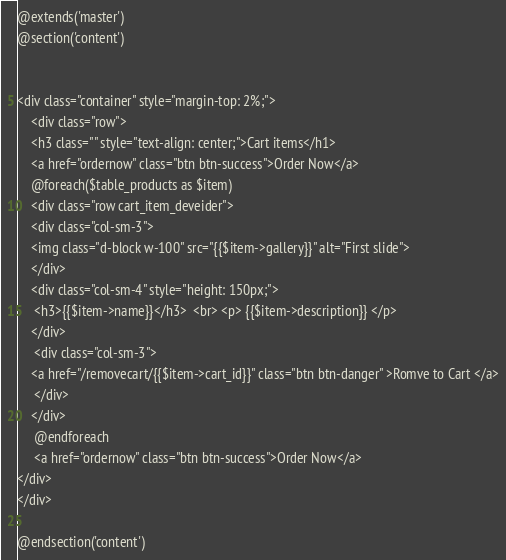Convert code to text. <code><loc_0><loc_0><loc_500><loc_500><_PHP_>@extends('master')
@section('content')


<div class="container" style="margin-top: 2%;">
    <div class="row">
    <h3 class="" style="text-align: center;">Cart items</h1>
    <a href="ordernow" class="btn btn-success">Order Now</a>
    @foreach($table_products as $item)
    <div class="row cart_item_deveider">
    <div class="col-sm-3">
    <img class="d-block w-100" src="{{$item->gallery}}" alt="First slide">
    </div>
    <div class="col-sm-4" style="height: 150px;"> 
     <h3>{{$item->name}}</h3>  <br> <p> {{$item->description}} </p>
    </div>
     <div class="col-sm-3">
    <a href="/removecart/{{$item->cart_id}}" class="btn btn-danger" >Romve to Cart </a>
     </div>
    </div>
     @endforeach
     <a href="ordernow" class="btn btn-success">Order Now</a>
</div>
</div>

@endsection('content')</code> 